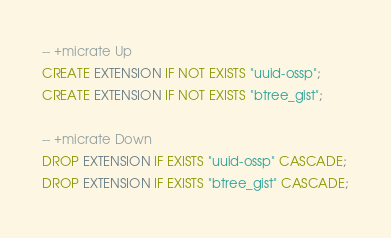<code> <loc_0><loc_0><loc_500><loc_500><_SQL_>-- +micrate Up
CREATE EXTENSION IF NOT EXISTS "uuid-ossp";
CREATE EXTENSION IF NOT EXISTS "btree_gist";

-- +micrate Down
DROP EXTENSION IF EXISTS "uuid-ossp" CASCADE;
DROP EXTENSION IF EXISTS "btree_gist" CASCADE;
</code> 